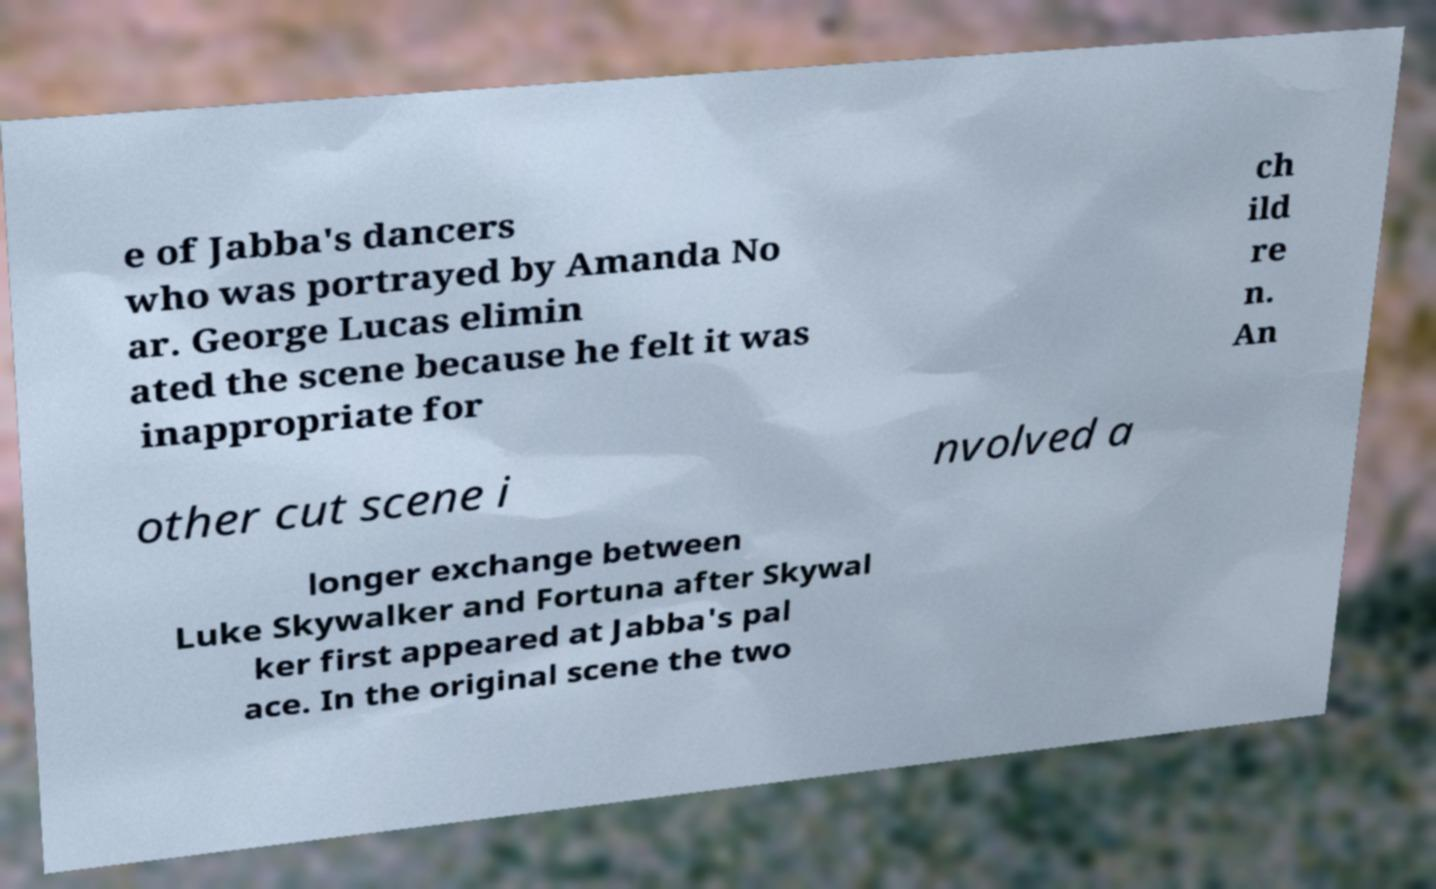There's text embedded in this image that I need extracted. Can you transcribe it verbatim? e of Jabba's dancers who was portrayed by Amanda No ar. George Lucas elimin ated the scene because he felt it was inappropriate for ch ild re n. An other cut scene i nvolved a longer exchange between Luke Skywalker and Fortuna after Skywal ker first appeared at Jabba's pal ace. In the original scene the two 